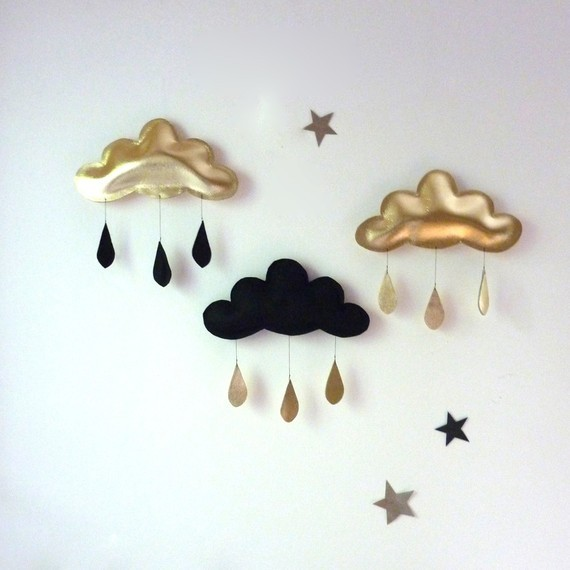Considering the symmetrical color scheme and the arrangement of the clouds and stars, what could be the significance or symbolism behind the alternating colors of the clouds and their respective raindrops? The alternating colors of the clouds and raindrops could symbolize a balance between two opposites or a yin-yang relationship. The golden clouds with black raindrops and the black cloud with golden raindrops may represent the idea that there is darkness in light and light in darkness, suggesting a philosophical or aesthetic balance. This concept is often found in art to visualize the interdependence of dualities. The image could be interpreted as an artistic representation of harmony and the unity of opposites. 